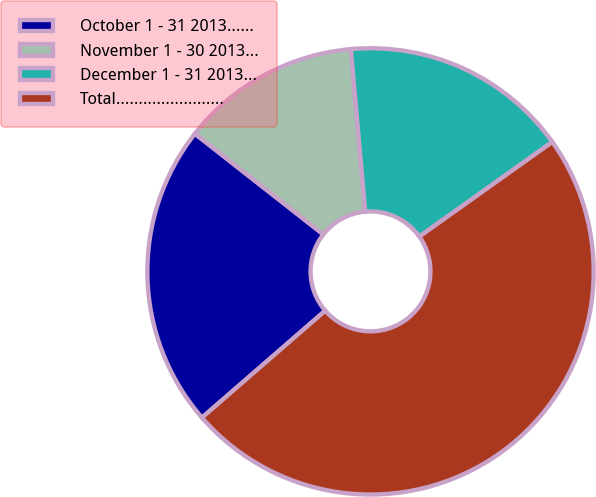<chart> <loc_0><loc_0><loc_500><loc_500><pie_chart><fcel>October 1 - 31 2013……<fcel>November 1 - 30 2013…<fcel>December 1 - 31 2013…<fcel>Total……………………<nl><fcel>21.96%<fcel>13.01%<fcel>16.56%<fcel>48.47%<nl></chart> 